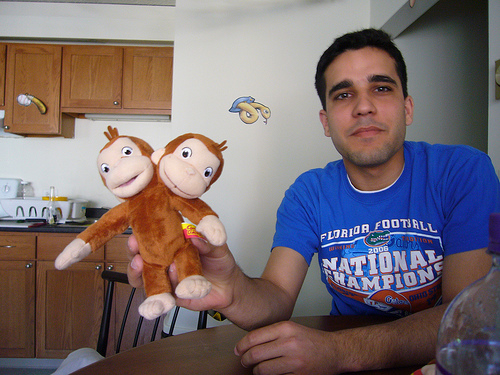<image>
Is there a snake to the right of the monkey? No. The snake is not to the right of the monkey. The horizontal positioning shows a different relationship. Where is the monkey in relation to the grip? Is it on the grip? Yes. Looking at the image, I can see the monkey is positioned on top of the grip, with the grip providing support. Is there a stuffed monkey on the table? No. The stuffed monkey is not positioned on the table. They may be near each other, but the stuffed monkey is not supported by or resting on top of the table. Is the chair behind the toy? Yes. From this viewpoint, the chair is positioned behind the toy, with the toy partially or fully occluding the chair. 